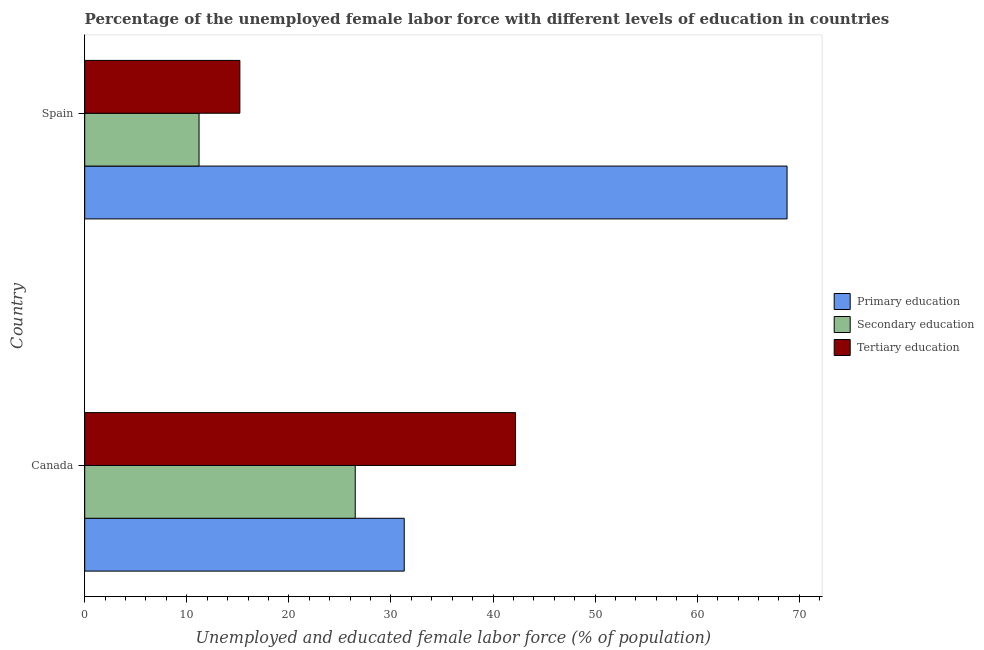Are the number of bars per tick equal to the number of legend labels?
Your response must be concise. Yes. Are the number of bars on each tick of the Y-axis equal?
Give a very brief answer. Yes. How many bars are there on the 1st tick from the bottom?
Your answer should be very brief. 3. What is the percentage of female labor force who received tertiary education in Spain?
Your answer should be compact. 15.2. Across all countries, what is the maximum percentage of female labor force who received secondary education?
Ensure brevity in your answer.  26.5. Across all countries, what is the minimum percentage of female labor force who received primary education?
Make the answer very short. 31.3. In which country was the percentage of female labor force who received tertiary education maximum?
Your response must be concise. Canada. What is the total percentage of female labor force who received tertiary education in the graph?
Provide a short and direct response. 57.4. What is the difference between the percentage of female labor force who received secondary education in Canada and that in Spain?
Give a very brief answer. 15.3. What is the difference between the percentage of female labor force who received secondary education in Canada and the percentage of female labor force who received tertiary education in Spain?
Your answer should be very brief. 11.3. What is the average percentage of female labor force who received tertiary education per country?
Provide a short and direct response. 28.7. What is the ratio of the percentage of female labor force who received tertiary education in Canada to that in Spain?
Make the answer very short. 2.78. Is the difference between the percentage of female labor force who received tertiary education in Canada and Spain greater than the difference between the percentage of female labor force who received secondary education in Canada and Spain?
Provide a succinct answer. Yes. In how many countries, is the percentage of female labor force who received secondary education greater than the average percentage of female labor force who received secondary education taken over all countries?
Offer a terse response. 1. What does the 2nd bar from the top in Canada represents?
Offer a very short reply. Secondary education. What does the 2nd bar from the bottom in Spain represents?
Provide a succinct answer. Secondary education. How many bars are there?
Ensure brevity in your answer.  6. What is the difference between two consecutive major ticks on the X-axis?
Offer a terse response. 10. Are the values on the major ticks of X-axis written in scientific E-notation?
Your response must be concise. No. Where does the legend appear in the graph?
Your response must be concise. Center right. How many legend labels are there?
Provide a succinct answer. 3. What is the title of the graph?
Offer a very short reply. Percentage of the unemployed female labor force with different levels of education in countries. What is the label or title of the X-axis?
Offer a very short reply. Unemployed and educated female labor force (% of population). What is the label or title of the Y-axis?
Offer a terse response. Country. What is the Unemployed and educated female labor force (% of population) in Primary education in Canada?
Provide a short and direct response. 31.3. What is the Unemployed and educated female labor force (% of population) in Secondary education in Canada?
Ensure brevity in your answer.  26.5. What is the Unemployed and educated female labor force (% of population) of Tertiary education in Canada?
Your response must be concise. 42.2. What is the Unemployed and educated female labor force (% of population) in Primary education in Spain?
Your answer should be very brief. 68.8. What is the Unemployed and educated female labor force (% of population) in Secondary education in Spain?
Ensure brevity in your answer.  11.2. What is the Unemployed and educated female labor force (% of population) in Tertiary education in Spain?
Your response must be concise. 15.2. Across all countries, what is the maximum Unemployed and educated female labor force (% of population) of Primary education?
Make the answer very short. 68.8. Across all countries, what is the maximum Unemployed and educated female labor force (% of population) in Secondary education?
Ensure brevity in your answer.  26.5. Across all countries, what is the maximum Unemployed and educated female labor force (% of population) of Tertiary education?
Offer a very short reply. 42.2. Across all countries, what is the minimum Unemployed and educated female labor force (% of population) of Primary education?
Your answer should be very brief. 31.3. Across all countries, what is the minimum Unemployed and educated female labor force (% of population) in Secondary education?
Your answer should be compact. 11.2. Across all countries, what is the minimum Unemployed and educated female labor force (% of population) of Tertiary education?
Your answer should be very brief. 15.2. What is the total Unemployed and educated female labor force (% of population) of Primary education in the graph?
Your response must be concise. 100.1. What is the total Unemployed and educated female labor force (% of population) of Secondary education in the graph?
Make the answer very short. 37.7. What is the total Unemployed and educated female labor force (% of population) of Tertiary education in the graph?
Provide a succinct answer. 57.4. What is the difference between the Unemployed and educated female labor force (% of population) of Primary education in Canada and that in Spain?
Give a very brief answer. -37.5. What is the difference between the Unemployed and educated female labor force (% of population) of Tertiary education in Canada and that in Spain?
Offer a terse response. 27. What is the difference between the Unemployed and educated female labor force (% of population) in Primary education in Canada and the Unemployed and educated female labor force (% of population) in Secondary education in Spain?
Offer a very short reply. 20.1. What is the difference between the Unemployed and educated female labor force (% of population) of Primary education in Canada and the Unemployed and educated female labor force (% of population) of Tertiary education in Spain?
Give a very brief answer. 16.1. What is the average Unemployed and educated female labor force (% of population) of Primary education per country?
Make the answer very short. 50.05. What is the average Unemployed and educated female labor force (% of population) in Secondary education per country?
Your answer should be compact. 18.85. What is the average Unemployed and educated female labor force (% of population) in Tertiary education per country?
Your answer should be very brief. 28.7. What is the difference between the Unemployed and educated female labor force (% of population) of Primary education and Unemployed and educated female labor force (% of population) of Secondary education in Canada?
Keep it short and to the point. 4.8. What is the difference between the Unemployed and educated female labor force (% of population) of Primary education and Unemployed and educated female labor force (% of population) of Tertiary education in Canada?
Make the answer very short. -10.9. What is the difference between the Unemployed and educated female labor force (% of population) in Secondary education and Unemployed and educated female labor force (% of population) in Tertiary education in Canada?
Make the answer very short. -15.7. What is the difference between the Unemployed and educated female labor force (% of population) in Primary education and Unemployed and educated female labor force (% of population) in Secondary education in Spain?
Your answer should be very brief. 57.6. What is the difference between the Unemployed and educated female labor force (% of population) in Primary education and Unemployed and educated female labor force (% of population) in Tertiary education in Spain?
Your response must be concise. 53.6. What is the ratio of the Unemployed and educated female labor force (% of population) in Primary education in Canada to that in Spain?
Your answer should be very brief. 0.45. What is the ratio of the Unemployed and educated female labor force (% of population) of Secondary education in Canada to that in Spain?
Give a very brief answer. 2.37. What is the ratio of the Unemployed and educated female labor force (% of population) in Tertiary education in Canada to that in Spain?
Provide a short and direct response. 2.78. What is the difference between the highest and the second highest Unemployed and educated female labor force (% of population) in Primary education?
Ensure brevity in your answer.  37.5. What is the difference between the highest and the second highest Unemployed and educated female labor force (% of population) of Secondary education?
Make the answer very short. 15.3. What is the difference between the highest and the second highest Unemployed and educated female labor force (% of population) of Tertiary education?
Make the answer very short. 27. What is the difference between the highest and the lowest Unemployed and educated female labor force (% of population) in Primary education?
Your response must be concise. 37.5. What is the difference between the highest and the lowest Unemployed and educated female labor force (% of population) in Tertiary education?
Ensure brevity in your answer.  27. 